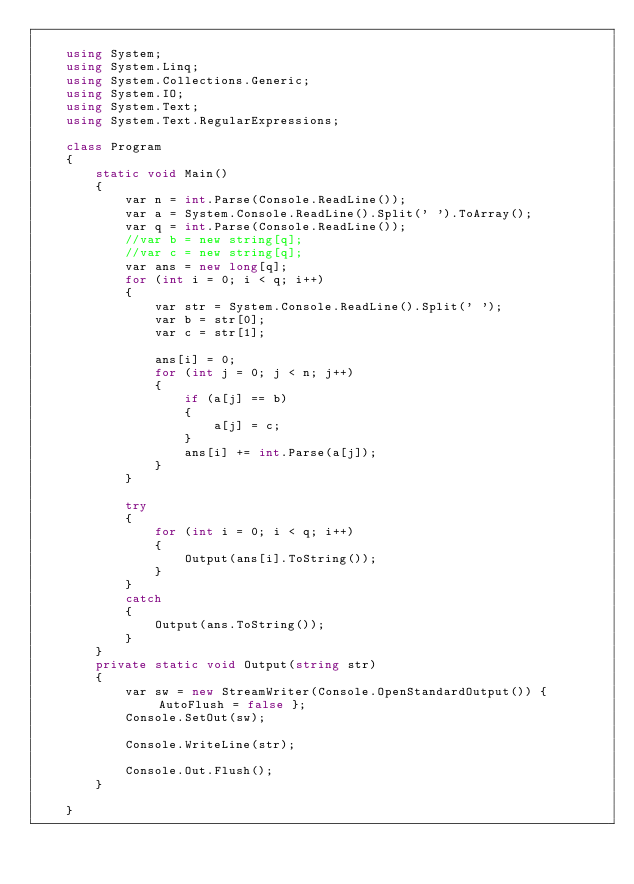Convert code to text. <code><loc_0><loc_0><loc_500><loc_500><_C#_>
    using System;
    using System.Linq;
    using System.Collections.Generic;
    using System.IO;
    using System.Text;
    using System.Text.RegularExpressions;

    class Program
    {
        static void Main()
        {
            var n = int.Parse(Console.ReadLine());
            var a = System.Console.ReadLine().Split(' ').ToArray();
            var q = int.Parse(Console.ReadLine());
            //var b = new string[q];
            //var c = new string[q];
            var ans = new long[q];
            for (int i = 0; i < q; i++)
            {
                var str = System.Console.ReadLine().Split(' ');
                var b = str[0];
                var c = str[1];

                ans[i] = 0;
                for (int j = 0; j < n; j++)
                {
                    if (a[j] == b)
                    {
                        a[j] = c;
                    }
                    ans[i] += int.Parse(a[j]);
                }
            }

            try
            {
                for (int i = 0; i < q; i++)
                {
                    Output(ans[i].ToString());
                }
            }
            catch
            {
                Output(ans.ToString());
            }
        }
        private static void Output(string str)
        {
            var sw = new StreamWriter(Console.OpenStandardOutput()) { AutoFlush = false };
            Console.SetOut(sw);

            Console.WriteLine(str);

            Console.Out.Flush();
        }

    }</code> 